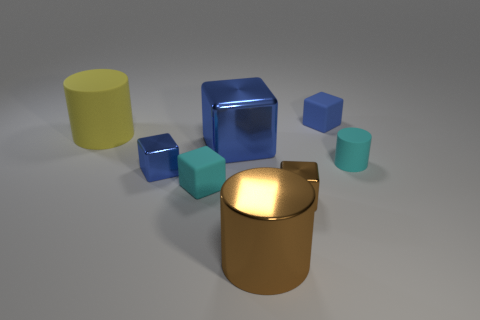Subtract all green balls. How many blue cubes are left? 3 Subtract all purple cubes. Subtract all blue balls. How many cubes are left? 5 Add 2 small red cylinders. How many objects exist? 10 Subtract all cylinders. How many objects are left? 5 Add 8 matte cylinders. How many matte cylinders are left? 10 Add 7 small rubber spheres. How many small rubber spheres exist? 7 Subtract 0 purple cubes. How many objects are left? 8 Subtract all small metal blocks. Subtract all matte objects. How many objects are left? 2 